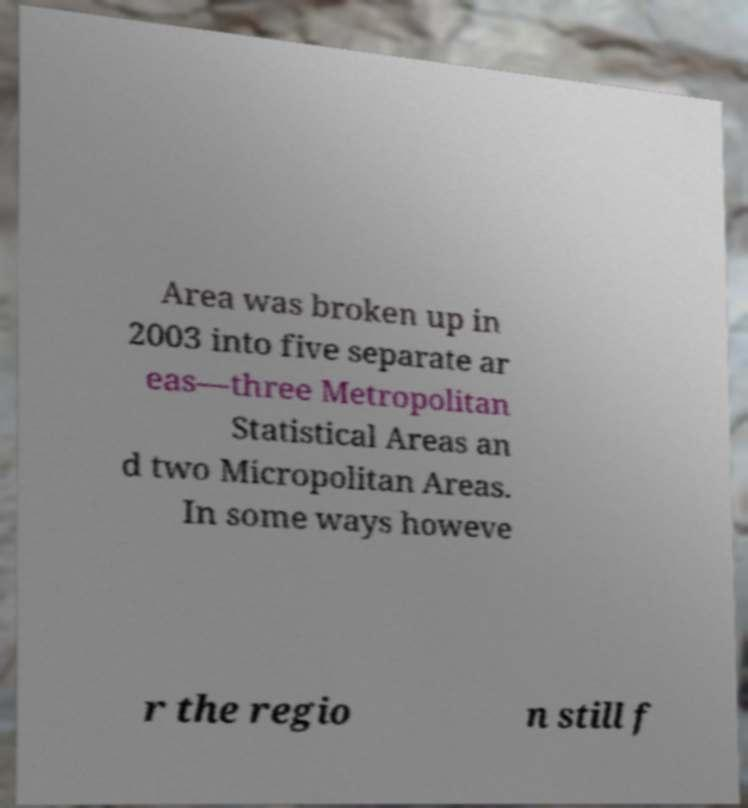Can you accurately transcribe the text from the provided image for me? Area was broken up in 2003 into five separate ar eas—three Metropolitan Statistical Areas an d two Micropolitan Areas. In some ways howeve r the regio n still f 